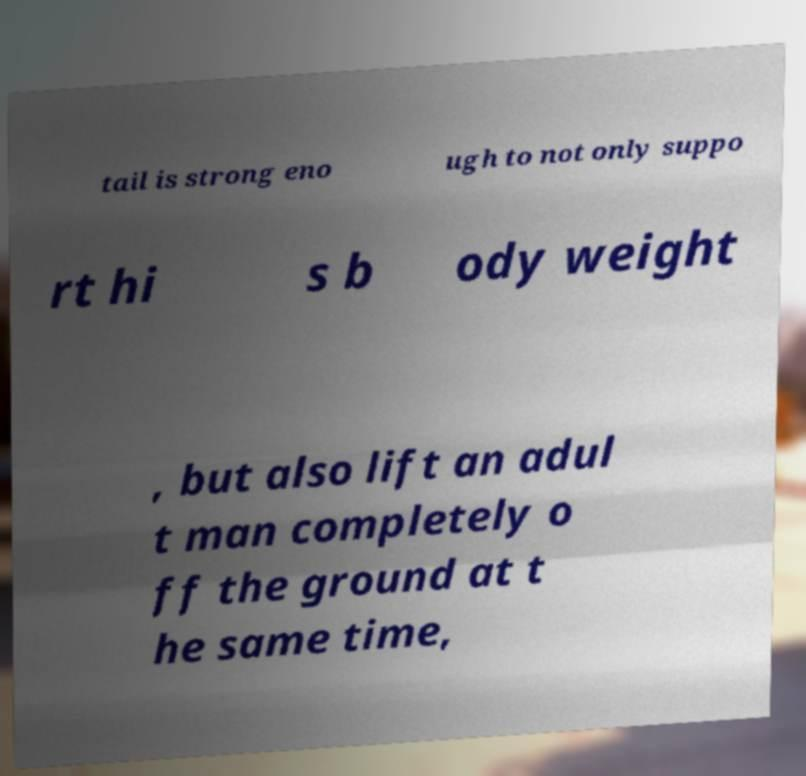Please identify and transcribe the text found in this image. tail is strong eno ugh to not only suppo rt hi s b ody weight , but also lift an adul t man completely o ff the ground at t he same time, 